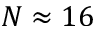Convert formula to latex. <formula><loc_0><loc_0><loc_500><loc_500>N \approx 1 6</formula> 